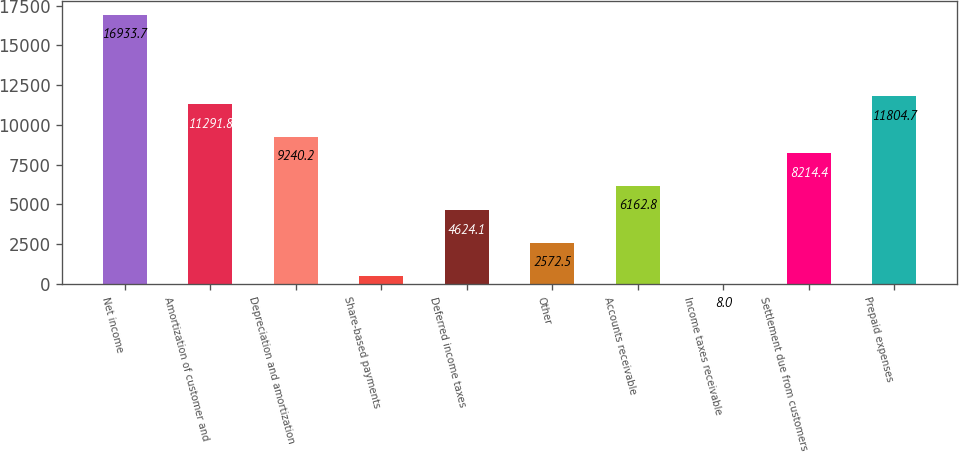Convert chart. <chart><loc_0><loc_0><loc_500><loc_500><bar_chart><fcel>Net income<fcel>Amortization of customer and<fcel>Depreciation and amortization<fcel>Share-based payments<fcel>Deferred income taxes<fcel>Other<fcel>Accounts receivable<fcel>Income taxes receivable<fcel>Settlement due from customers<fcel>Prepaid expenses<nl><fcel>16933.7<fcel>11291.8<fcel>9240.2<fcel>520.9<fcel>4624.1<fcel>2572.5<fcel>6162.8<fcel>8<fcel>8214.4<fcel>11804.7<nl></chart> 